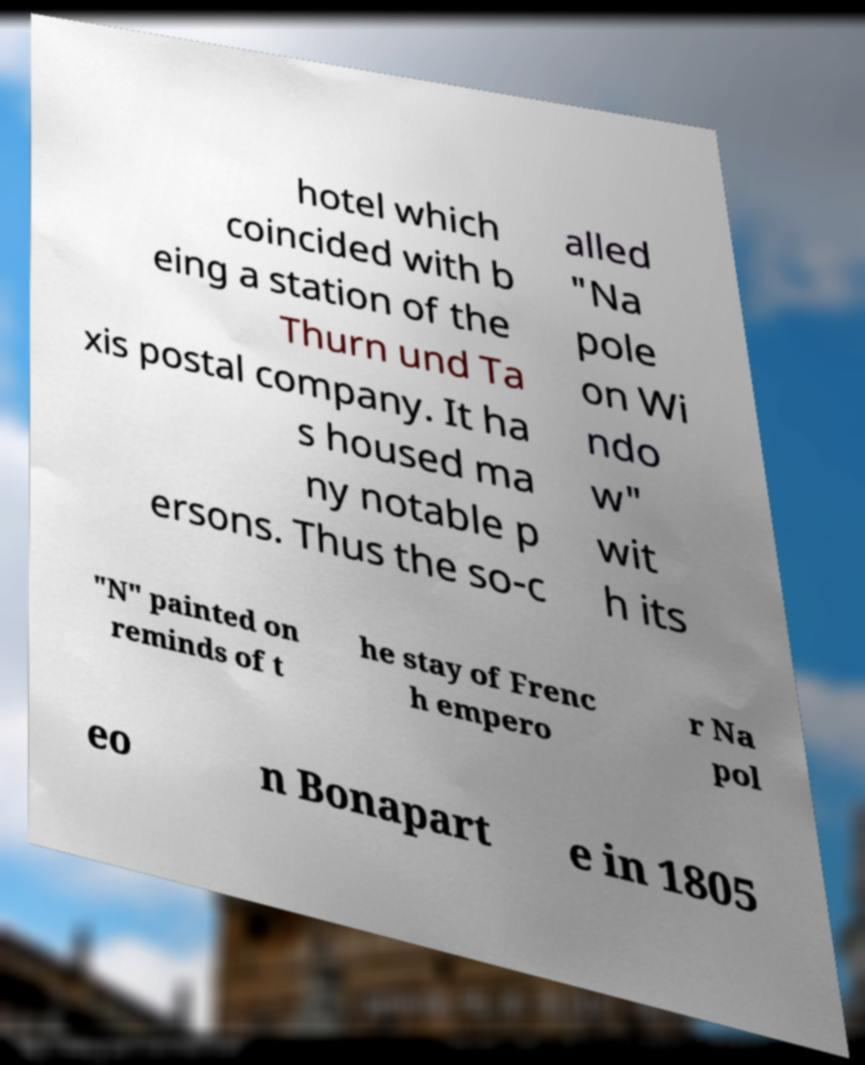For documentation purposes, I need the text within this image transcribed. Could you provide that? hotel which coincided with b eing a station of the Thurn und Ta xis postal company. It ha s housed ma ny notable p ersons. Thus the so-c alled "Na pole on Wi ndo w" wit h its "N" painted on reminds of t he stay of Frenc h empero r Na pol eo n Bonapart e in 1805 